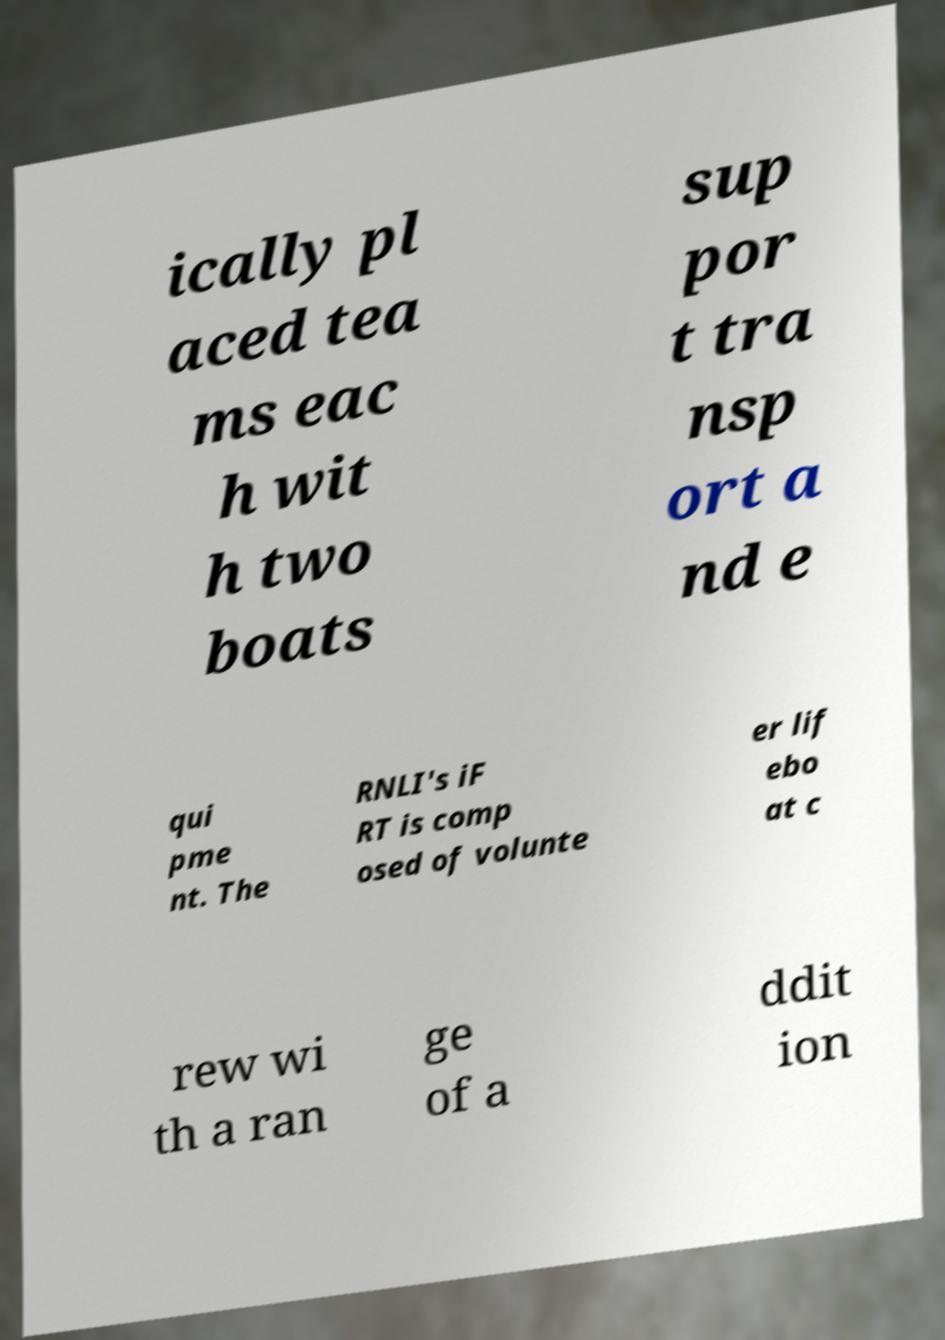Can you accurately transcribe the text from the provided image for me? ically pl aced tea ms eac h wit h two boats sup por t tra nsp ort a nd e qui pme nt. The RNLI's iF RT is comp osed of volunte er lif ebo at c rew wi th a ran ge of a ddit ion 